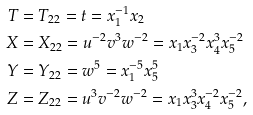<formula> <loc_0><loc_0><loc_500><loc_500>T & = T _ { 2 2 } = t = x _ { 1 } ^ { - 1 } x _ { 2 } \\ X & = X _ { 2 2 } = u ^ { - 2 } v ^ { 3 } w ^ { - 2 } = x _ { 1 } x _ { 3 } ^ { - 2 } x _ { 4 } ^ { 3 } x _ { 5 } ^ { - 2 } \\ Y & = Y _ { 2 2 } = w ^ { 5 } = x _ { 1 } ^ { - 5 } x _ { 5 } ^ { 5 } \\ Z & = Z _ { 2 2 } = u ^ { 3 } v ^ { - 2 } w ^ { - 2 } = x _ { 1 } x _ { 3 } ^ { 3 } x _ { 4 } ^ { - 2 } x _ { 5 } ^ { - 2 } ,</formula> 